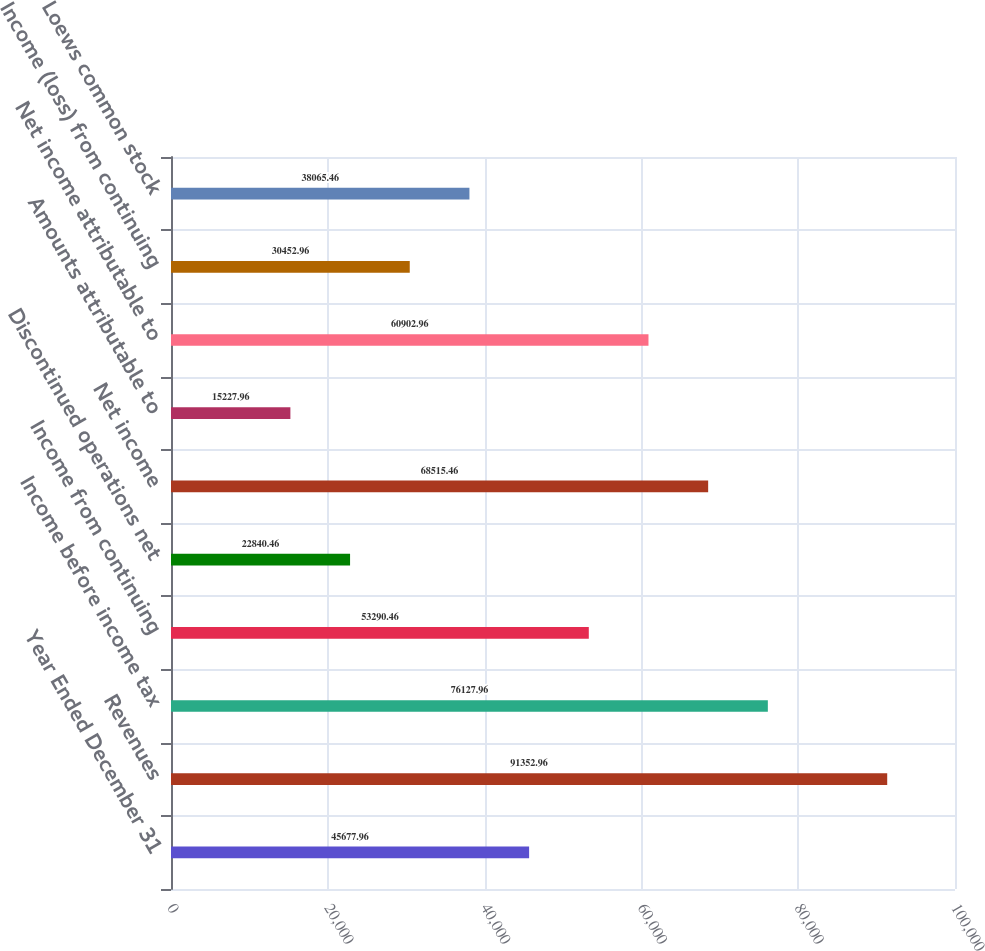Convert chart to OTSL. <chart><loc_0><loc_0><loc_500><loc_500><bar_chart><fcel>Year Ended December 31<fcel>Revenues<fcel>Income before income tax<fcel>Income from continuing<fcel>Discontinued operations net<fcel>Net income<fcel>Amounts attributable to<fcel>Net income attributable to<fcel>Income (loss) from continuing<fcel>Loews common stock<nl><fcel>45678<fcel>91353<fcel>76128<fcel>53290.5<fcel>22840.5<fcel>68515.5<fcel>15228<fcel>60903<fcel>30453<fcel>38065.5<nl></chart> 